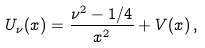<formula> <loc_0><loc_0><loc_500><loc_500>U _ { \nu } ( x ) = \frac { \nu ^ { 2 } - 1 / 4 } { x ^ { 2 } } + V ( x ) \, ,</formula> 